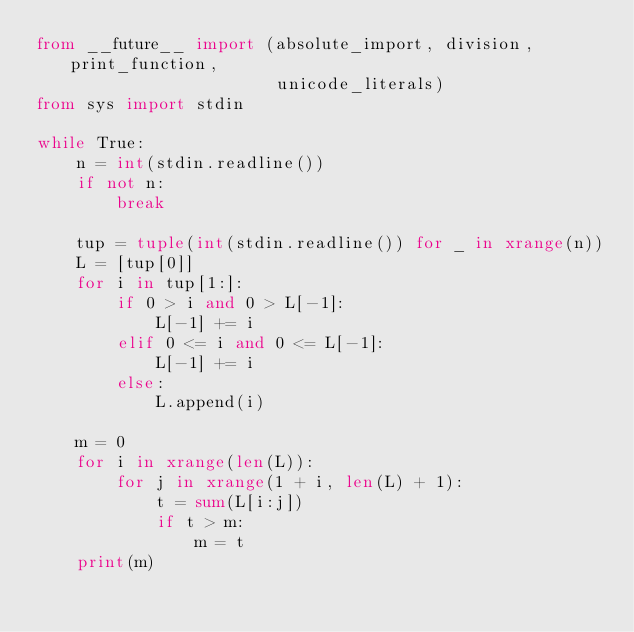<code> <loc_0><loc_0><loc_500><loc_500><_Python_>from __future__ import (absolute_import, division, print_function,
                        unicode_literals)
from sys import stdin

while True:
    n = int(stdin.readline())
    if not n:
        break

    tup = tuple(int(stdin.readline()) for _ in xrange(n))
    L = [tup[0]]
    for i in tup[1:]:
        if 0 > i and 0 > L[-1]:
            L[-1] += i
        elif 0 <= i and 0 <= L[-1]:
            L[-1] += i
        else:
            L.append(i)

    m = 0
    for i in xrange(len(L)):
        for j in xrange(1 + i, len(L) + 1):
            t = sum(L[i:j])
            if t > m:
                m = t
    print(m)</code> 